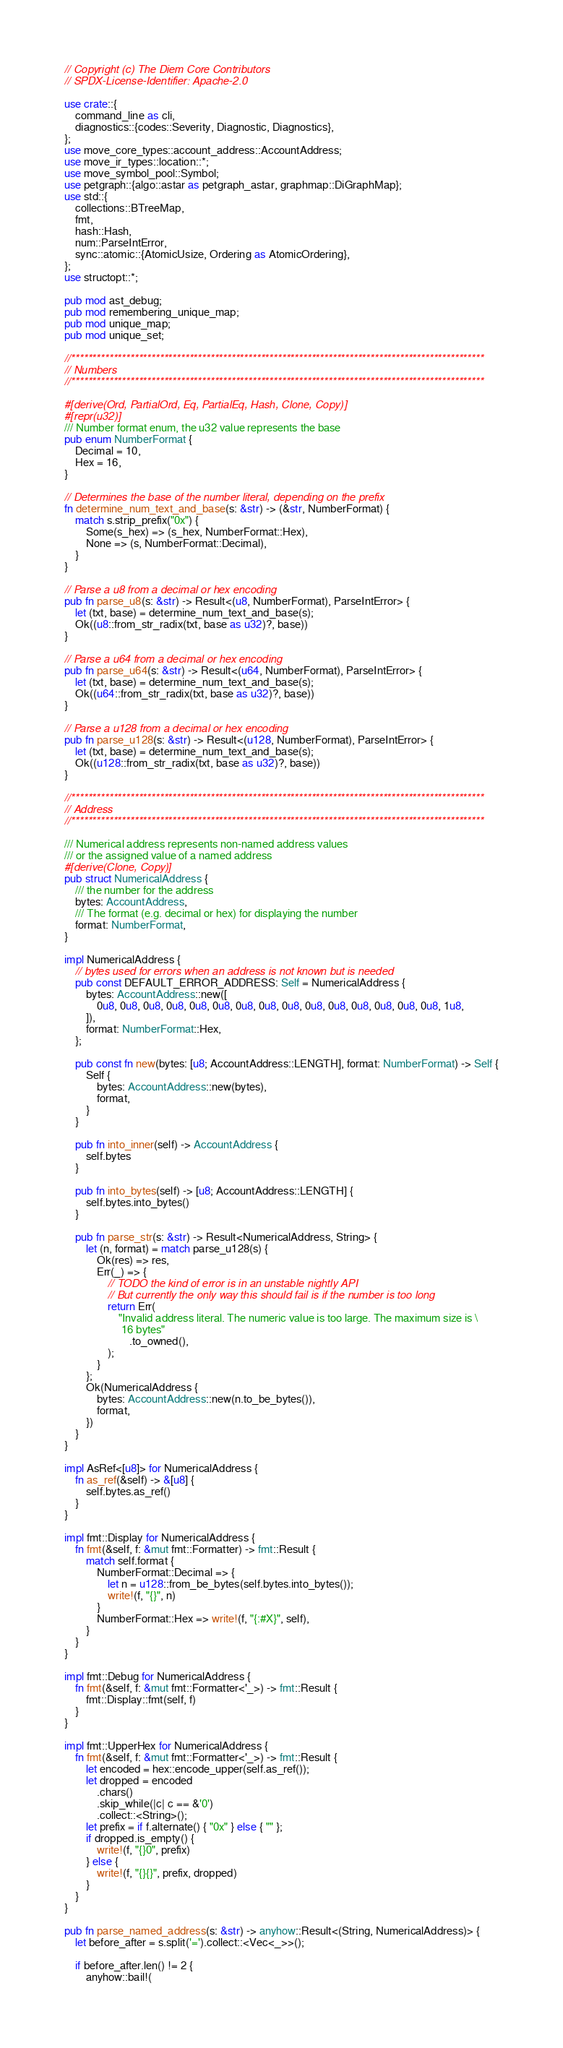<code> <loc_0><loc_0><loc_500><loc_500><_Rust_>// Copyright (c) The Diem Core Contributors
// SPDX-License-Identifier: Apache-2.0

use crate::{
    command_line as cli,
    diagnostics::{codes::Severity, Diagnostic, Diagnostics},
};
use move_core_types::account_address::AccountAddress;
use move_ir_types::location::*;
use move_symbol_pool::Symbol;
use petgraph::{algo::astar as petgraph_astar, graphmap::DiGraphMap};
use std::{
    collections::BTreeMap,
    fmt,
    hash::Hash,
    num::ParseIntError,
    sync::atomic::{AtomicUsize, Ordering as AtomicOrdering},
};
use structopt::*;

pub mod ast_debug;
pub mod remembering_unique_map;
pub mod unique_map;
pub mod unique_set;

//**************************************************************************************************
// Numbers
//**************************************************************************************************

#[derive(Ord, PartialOrd, Eq, PartialEq, Hash, Clone, Copy)]
#[repr(u32)]
/// Number format enum, the u32 value represents the base
pub enum NumberFormat {
    Decimal = 10,
    Hex = 16,
}

// Determines the base of the number literal, depending on the prefix
fn determine_num_text_and_base(s: &str) -> (&str, NumberFormat) {
    match s.strip_prefix("0x") {
        Some(s_hex) => (s_hex, NumberFormat::Hex),
        None => (s, NumberFormat::Decimal),
    }
}

// Parse a u8 from a decimal or hex encoding
pub fn parse_u8(s: &str) -> Result<(u8, NumberFormat), ParseIntError> {
    let (txt, base) = determine_num_text_and_base(s);
    Ok((u8::from_str_radix(txt, base as u32)?, base))
}

// Parse a u64 from a decimal or hex encoding
pub fn parse_u64(s: &str) -> Result<(u64, NumberFormat), ParseIntError> {
    let (txt, base) = determine_num_text_and_base(s);
    Ok((u64::from_str_radix(txt, base as u32)?, base))
}

// Parse a u128 from a decimal or hex encoding
pub fn parse_u128(s: &str) -> Result<(u128, NumberFormat), ParseIntError> {
    let (txt, base) = determine_num_text_and_base(s);
    Ok((u128::from_str_radix(txt, base as u32)?, base))
}

//**************************************************************************************************
// Address
//**************************************************************************************************

/// Numerical address represents non-named address values
/// or the assigned value of a named address
#[derive(Clone, Copy)]
pub struct NumericalAddress {
    /// the number for the address
    bytes: AccountAddress,
    /// The format (e.g. decimal or hex) for displaying the number
    format: NumberFormat,
}

impl NumericalAddress {
    // bytes used for errors when an address is not known but is needed
    pub const DEFAULT_ERROR_ADDRESS: Self = NumericalAddress {
        bytes: AccountAddress::new([
            0u8, 0u8, 0u8, 0u8, 0u8, 0u8, 0u8, 0u8, 0u8, 0u8, 0u8, 0u8, 0u8, 0u8, 0u8, 1u8,
        ]),
        format: NumberFormat::Hex,
    };

    pub const fn new(bytes: [u8; AccountAddress::LENGTH], format: NumberFormat) -> Self {
        Self {
            bytes: AccountAddress::new(bytes),
            format,
        }
    }

    pub fn into_inner(self) -> AccountAddress {
        self.bytes
    }

    pub fn into_bytes(self) -> [u8; AccountAddress::LENGTH] {
        self.bytes.into_bytes()
    }

    pub fn parse_str(s: &str) -> Result<NumericalAddress, String> {
        let (n, format) = match parse_u128(s) {
            Ok(res) => res,
            Err(_) => {
                // TODO the kind of error is in an unstable nightly API
                // But currently the only way this should fail is if the number is too long
                return Err(
                    "Invalid address literal. The numeric value is too large. The maximum size is \
                     16 bytes"
                        .to_owned(),
                );
            }
        };
        Ok(NumericalAddress {
            bytes: AccountAddress::new(n.to_be_bytes()),
            format,
        })
    }
}

impl AsRef<[u8]> for NumericalAddress {
    fn as_ref(&self) -> &[u8] {
        self.bytes.as_ref()
    }
}

impl fmt::Display for NumericalAddress {
    fn fmt(&self, f: &mut fmt::Formatter) -> fmt::Result {
        match self.format {
            NumberFormat::Decimal => {
                let n = u128::from_be_bytes(self.bytes.into_bytes());
                write!(f, "{}", n)
            }
            NumberFormat::Hex => write!(f, "{:#X}", self),
        }
    }
}

impl fmt::Debug for NumericalAddress {
    fn fmt(&self, f: &mut fmt::Formatter<'_>) -> fmt::Result {
        fmt::Display::fmt(self, f)
    }
}

impl fmt::UpperHex for NumericalAddress {
    fn fmt(&self, f: &mut fmt::Formatter<'_>) -> fmt::Result {
        let encoded = hex::encode_upper(self.as_ref());
        let dropped = encoded
            .chars()
            .skip_while(|c| c == &'0')
            .collect::<String>();
        let prefix = if f.alternate() { "0x" } else { "" };
        if dropped.is_empty() {
            write!(f, "{}0", prefix)
        } else {
            write!(f, "{}{}", prefix, dropped)
        }
    }
}

pub fn parse_named_address(s: &str) -> anyhow::Result<(String, NumericalAddress)> {
    let before_after = s.split('=').collect::<Vec<_>>();

    if before_after.len() != 2 {
        anyhow::bail!(</code> 